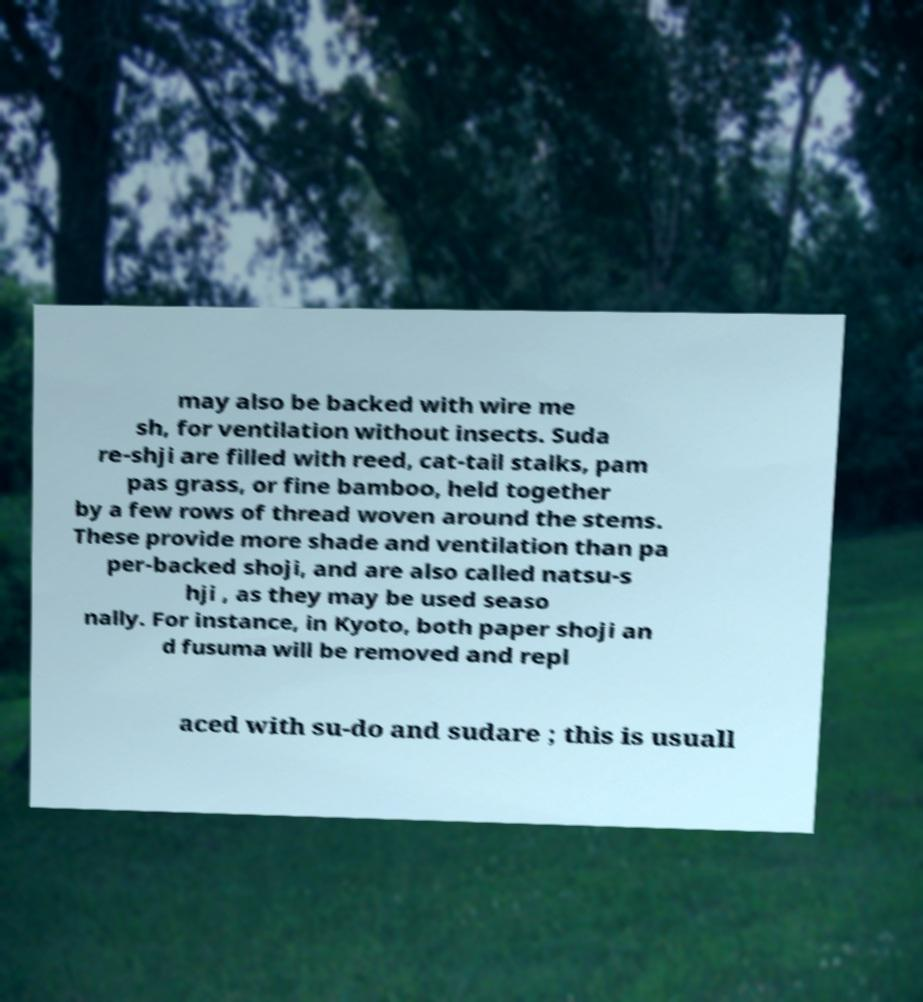Could you extract and type out the text from this image? may also be backed with wire me sh, for ventilation without insects. Suda re-shji are filled with reed, cat-tail stalks, pam pas grass, or fine bamboo, held together by a few rows of thread woven around the stems. These provide more shade and ventilation than pa per-backed shoji, and are also called natsu-s hji , as they may be used seaso nally. For instance, in Kyoto, both paper shoji an d fusuma will be removed and repl aced with su-do and sudare ; this is usuall 